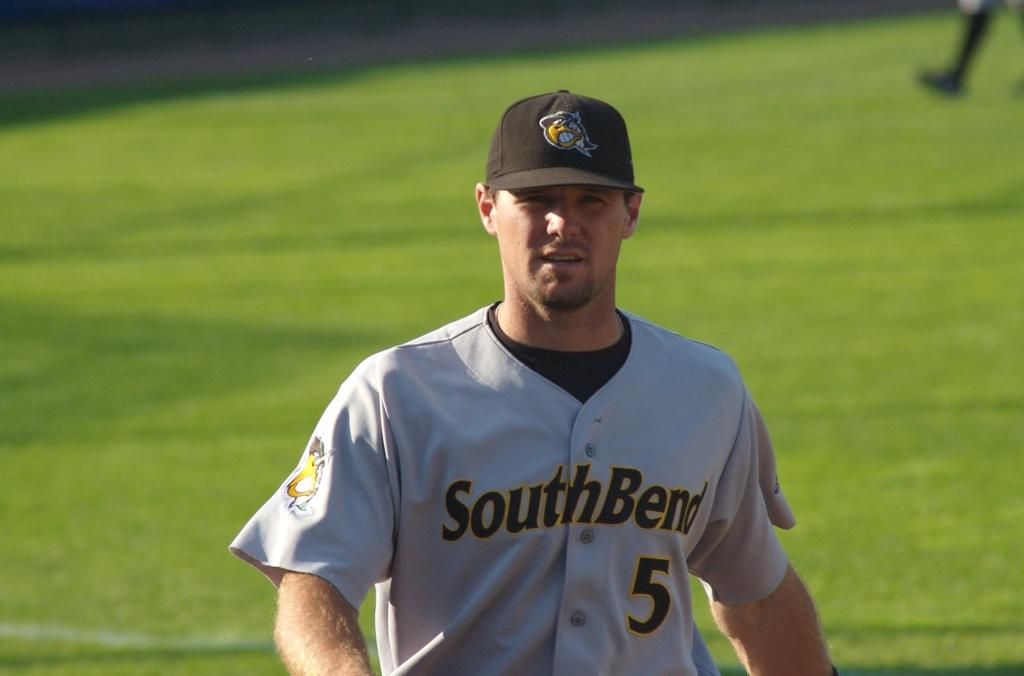<image>
Offer a succinct explanation of the picture presented. man wearing southbend #5 uniform staring ahead on the field 